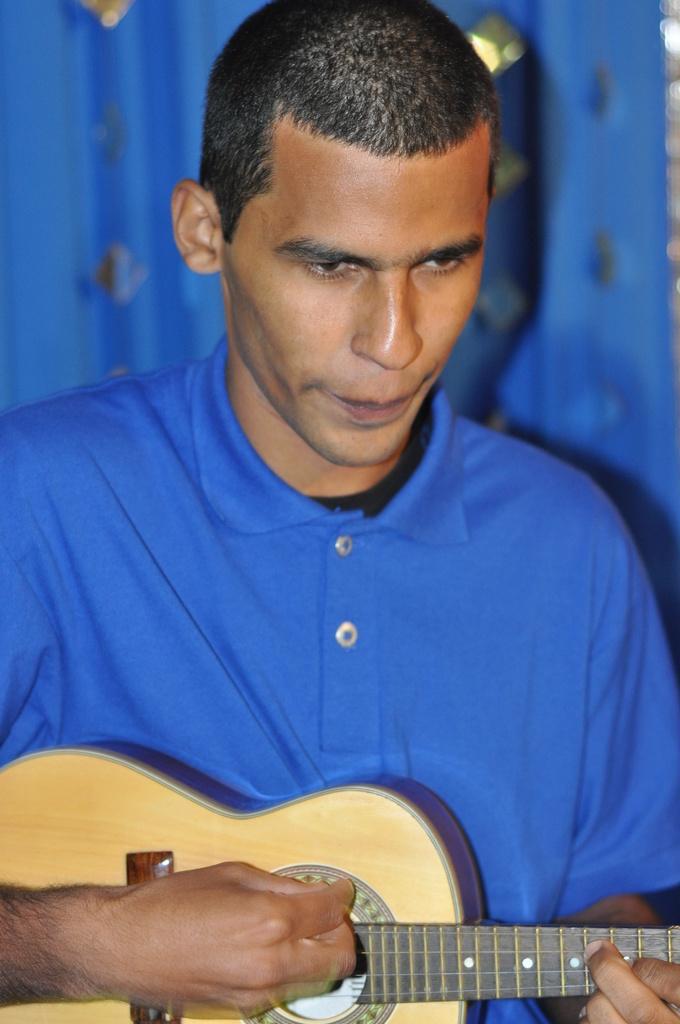Describe this image in one or two sentences. In this image we can see a man wearing blue t shirt is holding a guitar in his hands. 